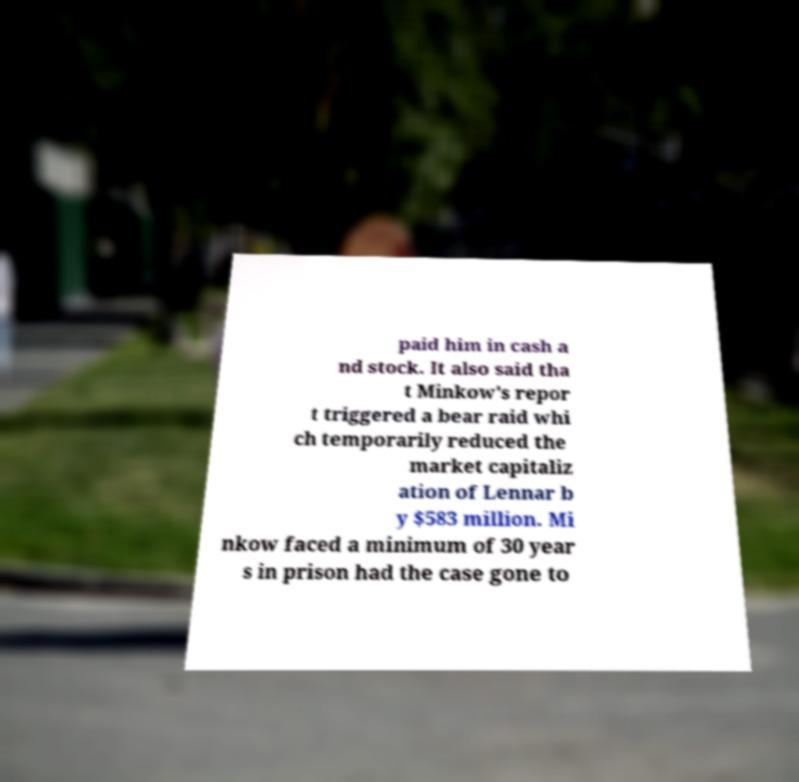Could you extract and type out the text from this image? paid him in cash a nd stock. It also said tha t Minkow's repor t triggered a bear raid whi ch temporarily reduced the market capitaliz ation of Lennar b y $583 million. Mi nkow faced a minimum of 30 year s in prison had the case gone to 